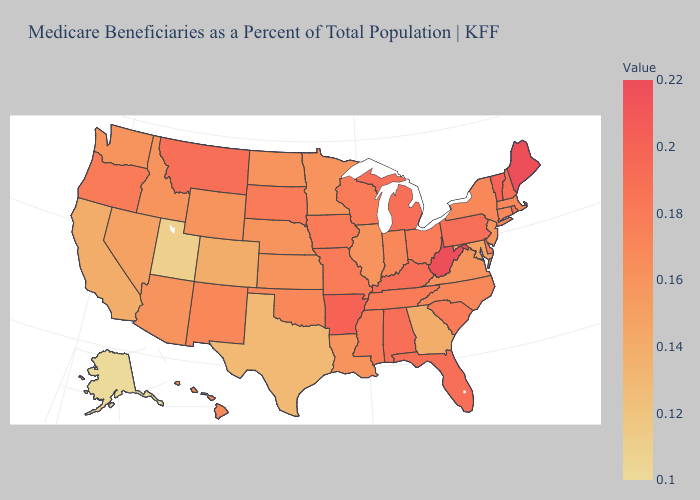Does California have the lowest value in the West?
Concise answer only. No. Does Louisiana have a lower value than Alabama?
Answer briefly. Yes. Which states have the highest value in the USA?
Keep it brief. Maine, West Virginia. 